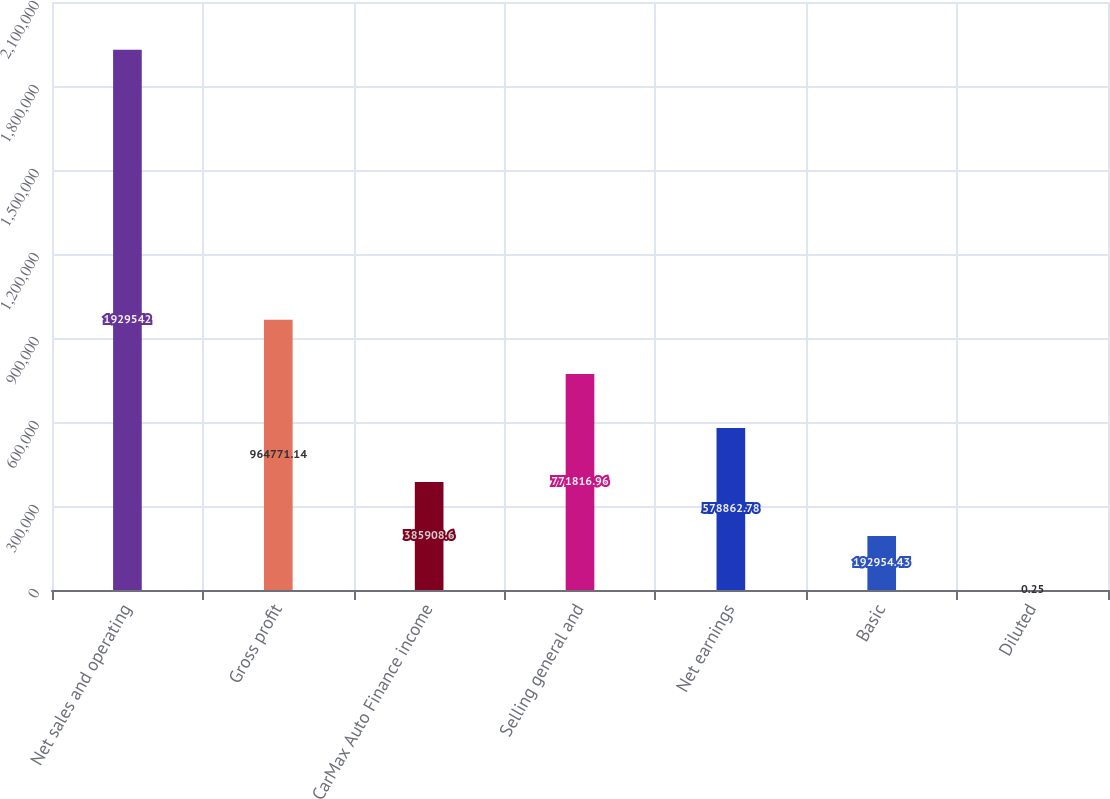Convert chart. <chart><loc_0><loc_0><loc_500><loc_500><bar_chart><fcel>Net sales and operating<fcel>Gross profit<fcel>CarMax Auto Finance income<fcel>Selling general and<fcel>Net earnings<fcel>Basic<fcel>Diluted<nl><fcel>1.92954e+06<fcel>964771<fcel>385909<fcel>771817<fcel>578863<fcel>192954<fcel>0.25<nl></chart> 